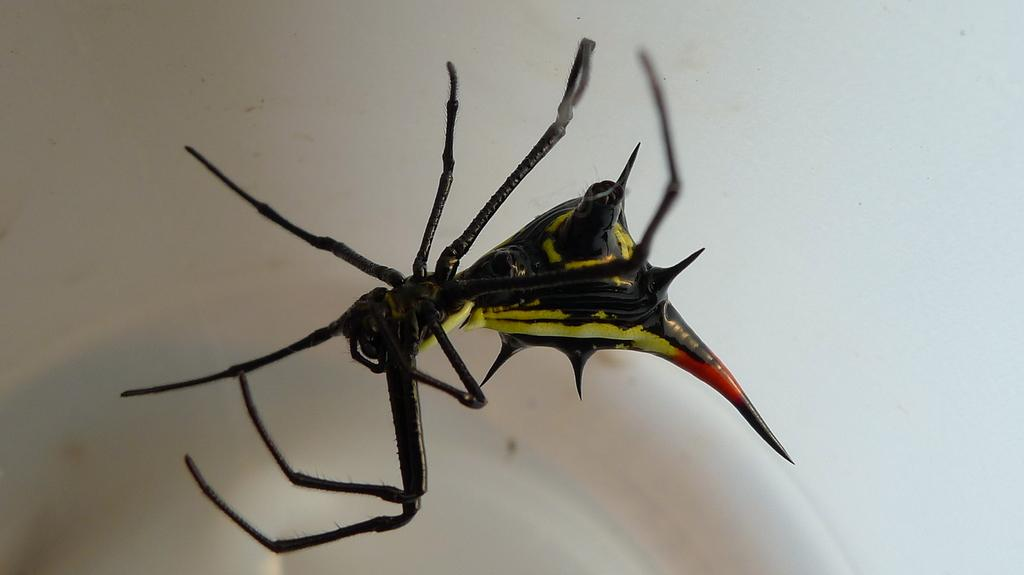What type of creature is present in the picture? There is an insect in the picture. What physical features does the insect have? The insect has legs and a body with black, yellow, and orange colors. What type of scarecrow is present in the picture? There is no scarecrow present in the picture; it features an insect. What type of motion can be observed in the image? The image is still, and there is no motion visible. 